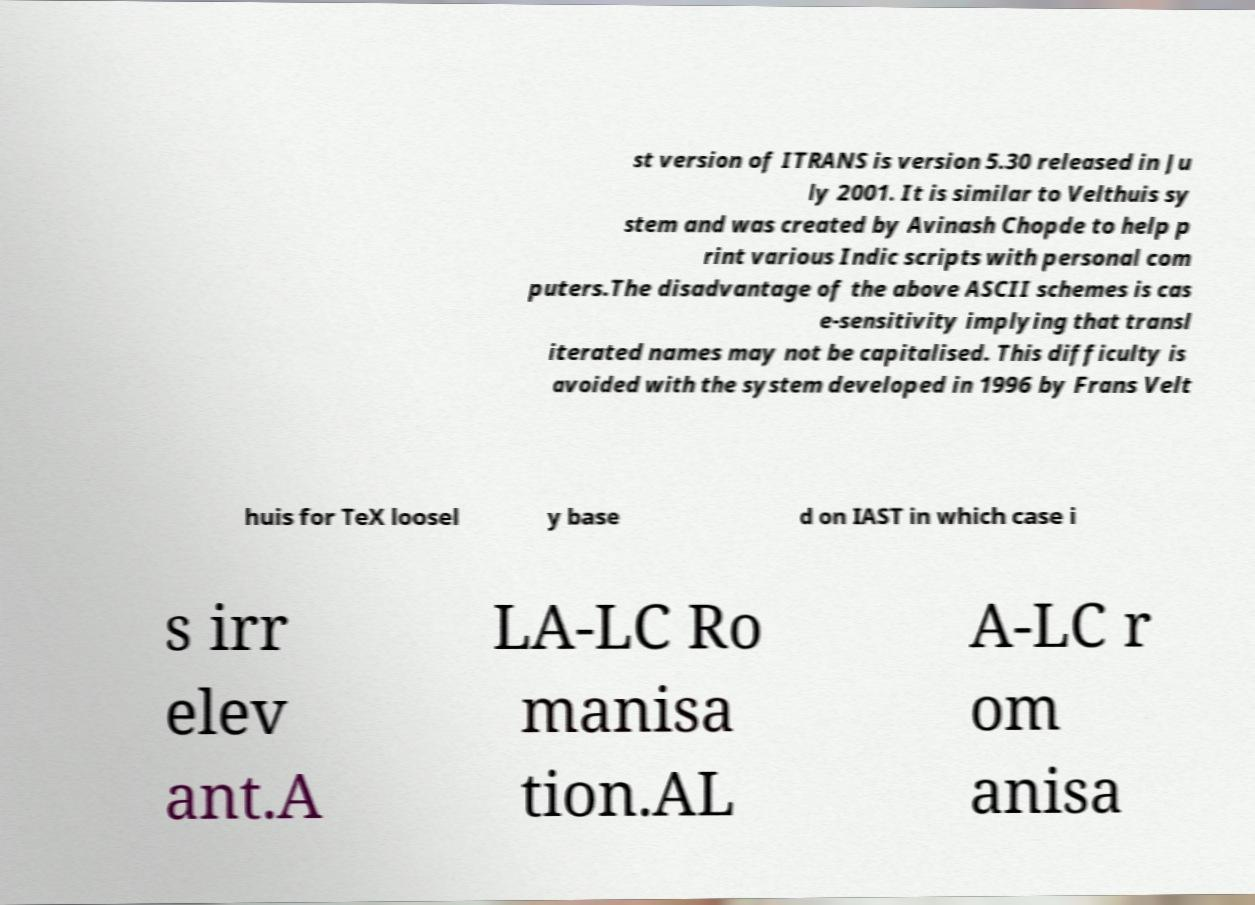What messages or text are displayed in this image? I need them in a readable, typed format. st version of ITRANS is version 5.30 released in Ju ly 2001. It is similar to Velthuis sy stem and was created by Avinash Chopde to help p rint various Indic scripts with personal com puters.The disadvantage of the above ASCII schemes is cas e-sensitivity implying that transl iterated names may not be capitalised. This difficulty is avoided with the system developed in 1996 by Frans Velt huis for TeX loosel y base d on IAST in which case i s irr elev ant.A LA-LC Ro manisa tion.AL A-LC r om anisa 